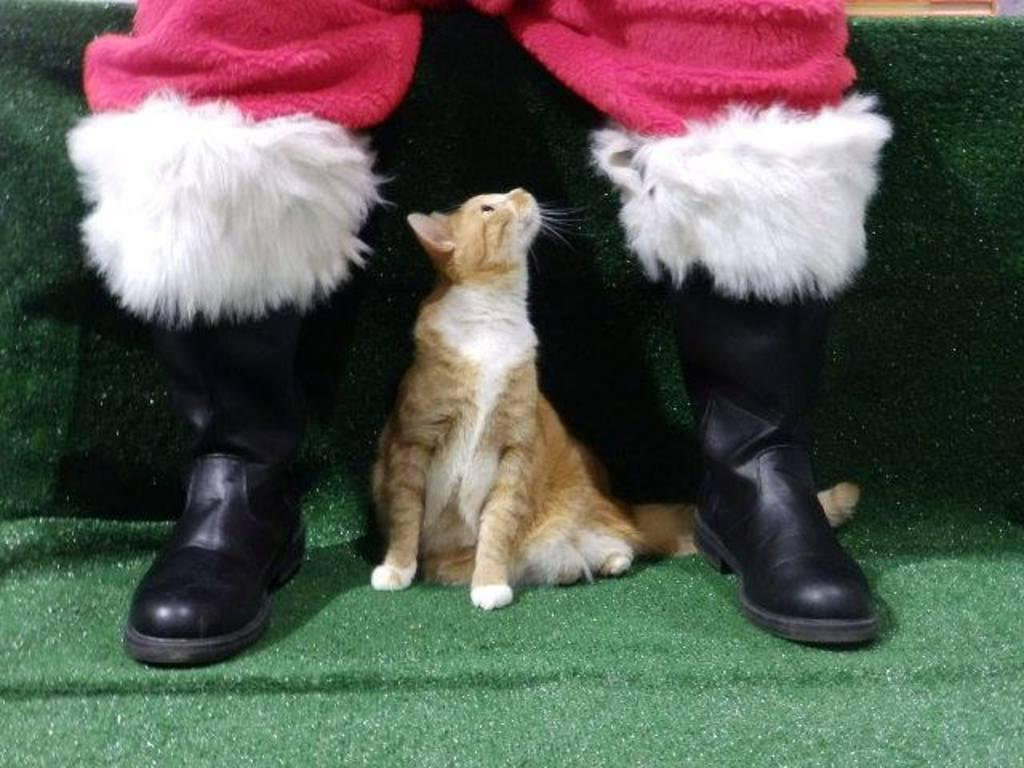What type of animal is in the image? There is a cat in the image. Can you describe the appearance of the cat? The cat is brown and white in color. What is the cat doing in the image? The cat is resting on the ground. Are there any people in the image? Yes, there are people in the image. Can you describe the clothing of one of the people? One person is wearing black shoes and a pink dress. What type of honey is being sold in the store in the image? There is no store or honey present in the image; it features a cat resting on the ground and people nearby. What type of battle is taking place in the image? There is no battle present in the image; it features a cat resting on the ground and people nearby. 